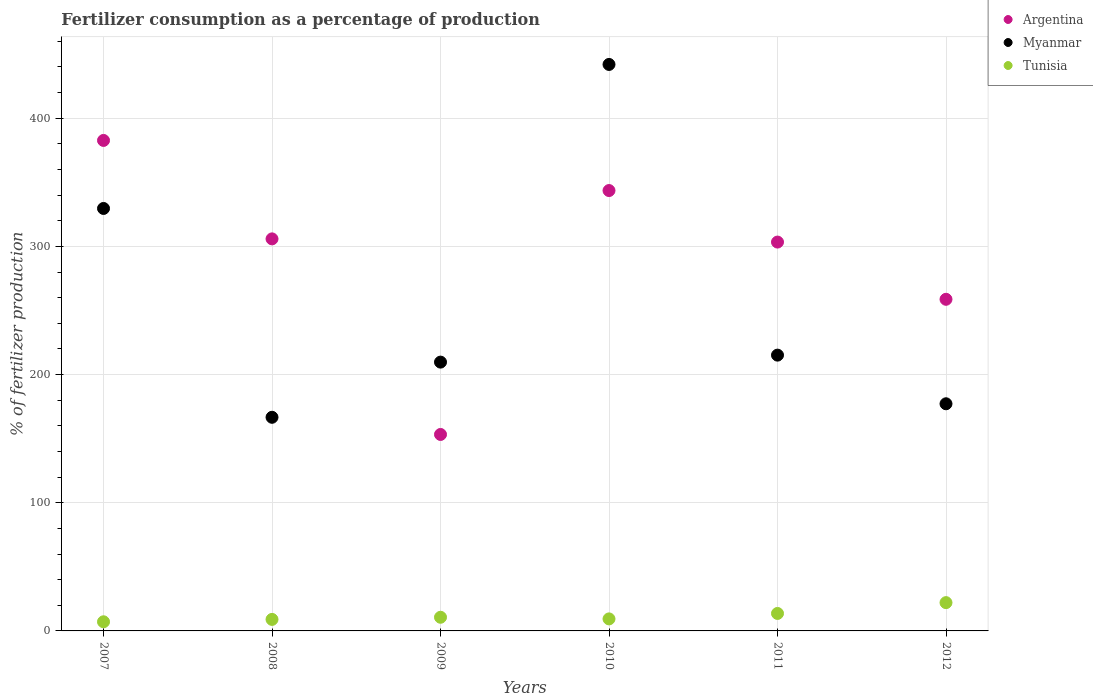Is the number of dotlines equal to the number of legend labels?
Your answer should be compact. Yes. What is the percentage of fertilizers consumed in Myanmar in 2008?
Make the answer very short. 166.68. Across all years, what is the maximum percentage of fertilizers consumed in Myanmar?
Offer a very short reply. 441.98. Across all years, what is the minimum percentage of fertilizers consumed in Argentina?
Offer a very short reply. 153.28. In which year was the percentage of fertilizers consumed in Tunisia maximum?
Offer a terse response. 2012. What is the total percentage of fertilizers consumed in Argentina in the graph?
Your answer should be very brief. 1747.57. What is the difference between the percentage of fertilizers consumed in Argentina in 2009 and that in 2010?
Give a very brief answer. -190.31. What is the difference between the percentage of fertilizers consumed in Myanmar in 2008 and the percentage of fertilizers consumed in Argentina in 2010?
Offer a very short reply. -176.91. What is the average percentage of fertilizers consumed in Argentina per year?
Keep it short and to the point. 291.26. In the year 2008, what is the difference between the percentage of fertilizers consumed in Tunisia and percentage of fertilizers consumed in Argentina?
Ensure brevity in your answer.  -296.9. What is the ratio of the percentage of fertilizers consumed in Myanmar in 2007 to that in 2012?
Provide a short and direct response. 1.86. Is the percentage of fertilizers consumed in Tunisia in 2010 less than that in 2012?
Give a very brief answer. Yes. What is the difference between the highest and the second highest percentage of fertilizers consumed in Argentina?
Your answer should be compact. 39.1. What is the difference between the highest and the lowest percentage of fertilizers consumed in Tunisia?
Your response must be concise. 14.94. Is the sum of the percentage of fertilizers consumed in Argentina in 2007 and 2009 greater than the maximum percentage of fertilizers consumed in Myanmar across all years?
Your response must be concise. Yes. Is the percentage of fertilizers consumed in Argentina strictly greater than the percentage of fertilizers consumed in Tunisia over the years?
Ensure brevity in your answer.  Yes. How many dotlines are there?
Provide a succinct answer. 3. How many years are there in the graph?
Offer a very short reply. 6. What is the difference between two consecutive major ticks on the Y-axis?
Your answer should be compact. 100. Are the values on the major ticks of Y-axis written in scientific E-notation?
Your answer should be compact. No. Where does the legend appear in the graph?
Provide a short and direct response. Top right. How many legend labels are there?
Ensure brevity in your answer.  3. How are the legend labels stacked?
Your response must be concise. Vertical. What is the title of the graph?
Offer a very short reply. Fertilizer consumption as a percentage of production. What is the label or title of the X-axis?
Your answer should be very brief. Years. What is the label or title of the Y-axis?
Offer a terse response. % of fertilizer production. What is the % of fertilizer production of Argentina in 2007?
Your answer should be very brief. 382.69. What is the % of fertilizer production in Myanmar in 2007?
Your answer should be compact. 329.61. What is the % of fertilizer production of Tunisia in 2007?
Provide a succinct answer. 7.13. What is the % of fertilizer production of Argentina in 2008?
Provide a short and direct response. 305.88. What is the % of fertilizer production in Myanmar in 2008?
Offer a very short reply. 166.68. What is the % of fertilizer production of Tunisia in 2008?
Offer a terse response. 8.99. What is the % of fertilizer production of Argentina in 2009?
Your answer should be compact. 153.28. What is the % of fertilizer production of Myanmar in 2009?
Offer a very short reply. 209.73. What is the % of fertilizer production of Tunisia in 2009?
Provide a succinct answer. 10.66. What is the % of fertilizer production of Argentina in 2010?
Give a very brief answer. 343.59. What is the % of fertilizer production of Myanmar in 2010?
Ensure brevity in your answer.  441.98. What is the % of fertilizer production of Tunisia in 2010?
Make the answer very short. 9.38. What is the % of fertilizer production of Argentina in 2011?
Make the answer very short. 303.39. What is the % of fertilizer production in Myanmar in 2011?
Your response must be concise. 215.18. What is the % of fertilizer production of Tunisia in 2011?
Offer a very short reply. 13.63. What is the % of fertilizer production of Argentina in 2012?
Give a very brief answer. 258.74. What is the % of fertilizer production in Myanmar in 2012?
Provide a succinct answer. 177.22. What is the % of fertilizer production in Tunisia in 2012?
Offer a very short reply. 22.07. Across all years, what is the maximum % of fertilizer production in Argentina?
Your response must be concise. 382.69. Across all years, what is the maximum % of fertilizer production in Myanmar?
Your answer should be compact. 441.98. Across all years, what is the maximum % of fertilizer production in Tunisia?
Make the answer very short. 22.07. Across all years, what is the minimum % of fertilizer production in Argentina?
Keep it short and to the point. 153.28. Across all years, what is the minimum % of fertilizer production in Myanmar?
Provide a short and direct response. 166.68. Across all years, what is the minimum % of fertilizer production in Tunisia?
Keep it short and to the point. 7.13. What is the total % of fertilizer production of Argentina in the graph?
Make the answer very short. 1747.57. What is the total % of fertilizer production of Myanmar in the graph?
Ensure brevity in your answer.  1540.39. What is the total % of fertilizer production of Tunisia in the graph?
Offer a terse response. 71.85. What is the difference between the % of fertilizer production in Argentina in 2007 and that in 2008?
Ensure brevity in your answer.  76.81. What is the difference between the % of fertilizer production in Myanmar in 2007 and that in 2008?
Your response must be concise. 162.93. What is the difference between the % of fertilizer production in Tunisia in 2007 and that in 2008?
Make the answer very short. -1.86. What is the difference between the % of fertilizer production of Argentina in 2007 and that in 2009?
Offer a very short reply. 229.41. What is the difference between the % of fertilizer production in Myanmar in 2007 and that in 2009?
Offer a terse response. 119.89. What is the difference between the % of fertilizer production in Tunisia in 2007 and that in 2009?
Offer a terse response. -3.53. What is the difference between the % of fertilizer production in Argentina in 2007 and that in 2010?
Provide a short and direct response. 39.1. What is the difference between the % of fertilizer production of Myanmar in 2007 and that in 2010?
Provide a short and direct response. -112.36. What is the difference between the % of fertilizer production of Tunisia in 2007 and that in 2010?
Keep it short and to the point. -2.25. What is the difference between the % of fertilizer production in Argentina in 2007 and that in 2011?
Ensure brevity in your answer.  79.3. What is the difference between the % of fertilizer production in Myanmar in 2007 and that in 2011?
Give a very brief answer. 114.44. What is the difference between the % of fertilizer production of Tunisia in 2007 and that in 2011?
Make the answer very short. -6.5. What is the difference between the % of fertilizer production of Argentina in 2007 and that in 2012?
Offer a very short reply. 123.95. What is the difference between the % of fertilizer production in Myanmar in 2007 and that in 2012?
Give a very brief answer. 152.39. What is the difference between the % of fertilizer production in Tunisia in 2007 and that in 2012?
Provide a short and direct response. -14.94. What is the difference between the % of fertilizer production of Argentina in 2008 and that in 2009?
Your response must be concise. 152.6. What is the difference between the % of fertilizer production of Myanmar in 2008 and that in 2009?
Your answer should be compact. -43.05. What is the difference between the % of fertilizer production in Tunisia in 2008 and that in 2009?
Make the answer very short. -1.67. What is the difference between the % of fertilizer production of Argentina in 2008 and that in 2010?
Give a very brief answer. -37.71. What is the difference between the % of fertilizer production in Myanmar in 2008 and that in 2010?
Offer a terse response. -275.3. What is the difference between the % of fertilizer production of Tunisia in 2008 and that in 2010?
Provide a short and direct response. -0.4. What is the difference between the % of fertilizer production of Argentina in 2008 and that in 2011?
Your answer should be compact. 2.49. What is the difference between the % of fertilizer production of Myanmar in 2008 and that in 2011?
Your response must be concise. -48.5. What is the difference between the % of fertilizer production of Tunisia in 2008 and that in 2011?
Keep it short and to the point. -4.65. What is the difference between the % of fertilizer production of Argentina in 2008 and that in 2012?
Offer a terse response. 47.14. What is the difference between the % of fertilizer production of Myanmar in 2008 and that in 2012?
Your response must be concise. -10.54. What is the difference between the % of fertilizer production of Tunisia in 2008 and that in 2012?
Keep it short and to the point. -13.08. What is the difference between the % of fertilizer production of Argentina in 2009 and that in 2010?
Keep it short and to the point. -190.31. What is the difference between the % of fertilizer production in Myanmar in 2009 and that in 2010?
Your response must be concise. -232.25. What is the difference between the % of fertilizer production in Tunisia in 2009 and that in 2010?
Your response must be concise. 1.27. What is the difference between the % of fertilizer production in Argentina in 2009 and that in 2011?
Your answer should be compact. -150.11. What is the difference between the % of fertilizer production in Myanmar in 2009 and that in 2011?
Give a very brief answer. -5.45. What is the difference between the % of fertilizer production of Tunisia in 2009 and that in 2011?
Provide a succinct answer. -2.97. What is the difference between the % of fertilizer production of Argentina in 2009 and that in 2012?
Provide a short and direct response. -105.46. What is the difference between the % of fertilizer production in Myanmar in 2009 and that in 2012?
Offer a very short reply. 32.51. What is the difference between the % of fertilizer production in Tunisia in 2009 and that in 2012?
Ensure brevity in your answer.  -11.41. What is the difference between the % of fertilizer production of Argentina in 2010 and that in 2011?
Offer a very short reply. 40.2. What is the difference between the % of fertilizer production of Myanmar in 2010 and that in 2011?
Keep it short and to the point. 226.8. What is the difference between the % of fertilizer production in Tunisia in 2010 and that in 2011?
Keep it short and to the point. -4.25. What is the difference between the % of fertilizer production in Argentina in 2010 and that in 2012?
Your answer should be compact. 84.85. What is the difference between the % of fertilizer production in Myanmar in 2010 and that in 2012?
Your response must be concise. 264.76. What is the difference between the % of fertilizer production in Tunisia in 2010 and that in 2012?
Keep it short and to the point. -12.69. What is the difference between the % of fertilizer production of Argentina in 2011 and that in 2012?
Your response must be concise. 44.65. What is the difference between the % of fertilizer production in Myanmar in 2011 and that in 2012?
Make the answer very short. 37.96. What is the difference between the % of fertilizer production of Tunisia in 2011 and that in 2012?
Offer a very short reply. -8.44. What is the difference between the % of fertilizer production in Argentina in 2007 and the % of fertilizer production in Myanmar in 2008?
Your answer should be very brief. 216.01. What is the difference between the % of fertilizer production of Argentina in 2007 and the % of fertilizer production of Tunisia in 2008?
Offer a very short reply. 373.7. What is the difference between the % of fertilizer production in Myanmar in 2007 and the % of fertilizer production in Tunisia in 2008?
Your response must be concise. 320.63. What is the difference between the % of fertilizer production in Argentina in 2007 and the % of fertilizer production in Myanmar in 2009?
Make the answer very short. 172.96. What is the difference between the % of fertilizer production in Argentina in 2007 and the % of fertilizer production in Tunisia in 2009?
Provide a short and direct response. 372.03. What is the difference between the % of fertilizer production in Myanmar in 2007 and the % of fertilizer production in Tunisia in 2009?
Give a very brief answer. 318.96. What is the difference between the % of fertilizer production of Argentina in 2007 and the % of fertilizer production of Myanmar in 2010?
Offer a terse response. -59.29. What is the difference between the % of fertilizer production of Argentina in 2007 and the % of fertilizer production of Tunisia in 2010?
Your answer should be compact. 373.3. What is the difference between the % of fertilizer production of Myanmar in 2007 and the % of fertilizer production of Tunisia in 2010?
Ensure brevity in your answer.  320.23. What is the difference between the % of fertilizer production of Argentina in 2007 and the % of fertilizer production of Myanmar in 2011?
Your answer should be compact. 167.51. What is the difference between the % of fertilizer production of Argentina in 2007 and the % of fertilizer production of Tunisia in 2011?
Keep it short and to the point. 369.06. What is the difference between the % of fertilizer production in Myanmar in 2007 and the % of fertilizer production in Tunisia in 2011?
Offer a terse response. 315.98. What is the difference between the % of fertilizer production of Argentina in 2007 and the % of fertilizer production of Myanmar in 2012?
Provide a short and direct response. 205.47. What is the difference between the % of fertilizer production of Argentina in 2007 and the % of fertilizer production of Tunisia in 2012?
Your answer should be compact. 360.62. What is the difference between the % of fertilizer production of Myanmar in 2007 and the % of fertilizer production of Tunisia in 2012?
Provide a succinct answer. 307.54. What is the difference between the % of fertilizer production of Argentina in 2008 and the % of fertilizer production of Myanmar in 2009?
Your response must be concise. 96.15. What is the difference between the % of fertilizer production of Argentina in 2008 and the % of fertilizer production of Tunisia in 2009?
Provide a short and direct response. 295.22. What is the difference between the % of fertilizer production in Myanmar in 2008 and the % of fertilizer production in Tunisia in 2009?
Your answer should be compact. 156.02. What is the difference between the % of fertilizer production in Argentina in 2008 and the % of fertilizer production in Myanmar in 2010?
Offer a terse response. -136.1. What is the difference between the % of fertilizer production of Argentina in 2008 and the % of fertilizer production of Tunisia in 2010?
Your answer should be compact. 296.5. What is the difference between the % of fertilizer production in Myanmar in 2008 and the % of fertilizer production in Tunisia in 2010?
Your response must be concise. 157.3. What is the difference between the % of fertilizer production of Argentina in 2008 and the % of fertilizer production of Myanmar in 2011?
Give a very brief answer. 90.7. What is the difference between the % of fertilizer production of Argentina in 2008 and the % of fertilizer production of Tunisia in 2011?
Keep it short and to the point. 292.25. What is the difference between the % of fertilizer production in Myanmar in 2008 and the % of fertilizer production in Tunisia in 2011?
Your answer should be compact. 153.05. What is the difference between the % of fertilizer production of Argentina in 2008 and the % of fertilizer production of Myanmar in 2012?
Your response must be concise. 128.66. What is the difference between the % of fertilizer production of Argentina in 2008 and the % of fertilizer production of Tunisia in 2012?
Ensure brevity in your answer.  283.81. What is the difference between the % of fertilizer production of Myanmar in 2008 and the % of fertilizer production of Tunisia in 2012?
Your response must be concise. 144.61. What is the difference between the % of fertilizer production in Argentina in 2009 and the % of fertilizer production in Myanmar in 2010?
Offer a terse response. -288.7. What is the difference between the % of fertilizer production in Argentina in 2009 and the % of fertilizer production in Tunisia in 2010?
Your response must be concise. 143.9. What is the difference between the % of fertilizer production in Myanmar in 2009 and the % of fertilizer production in Tunisia in 2010?
Offer a terse response. 200.34. What is the difference between the % of fertilizer production in Argentina in 2009 and the % of fertilizer production in Myanmar in 2011?
Keep it short and to the point. -61.9. What is the difference between the % of fertilizer production of Argentina in 2009 and the % of fertilizer production of Tunisia in 2011?
Make the answer very short. 139.65. What is the difference between the % of fertilizer production of Myanmar in 2009 and the % of fertilizer production of Tunisia in 2011?
Your answer should be very brief. 196.1. What is the difference between the % of fertilizer production of Argentina in 2009 and the % of fertilizer production of Myanmar in 2012?
Your answer should be very brief. -23.94. What is the difference between the % of fertilizer production in Argentina in 2009 and the % of fertilizer production in Tunisia in 2012?
Give a very brief answer. 131.21. What is the difference between the % of fertilizer production in Myanmar in 2009 and the % of fertilizer production in Tunisia in 2012?
Provide a succinct answer. 187.66. What is the difference between the % of fertilizer production of Argentina in 2010 and the % of fertilizer production of Myanmar in 2011?
Your answer should be compact. 128.41. What is the difference between the % of fertilizer production in Argentina in 2010 and the % of fertilizer production in Tunisia in 2011?
Your response must be concise. 329.96. What is the difference between the % of fertilizer production in Myanmar in 2010 and the % of fertilizer production in Tunisia in 2011?
Keep it short and to the point. 428.35. What is the difference between the % of fertilizer production of Argentina in 2010 and the % of fertilizer production of Myanmar in 2012?
Your answer should be very brief. 166.37. What is the difference between the % of fertilizer production in Argentina in 2010 and the % of fertilizer production in Tunisia in 2012?
Your response must be concise. 321.52. What is the difference between the % of fertilizer production of Myanmar in 2010 and the % of fertilizer production of Tunisia in 2012?
Provide a short and direct response. 419.91. What is the difference between the % of fertilizer production in Argentina in 2011 and the % of fertilizer production in Myanmar in 2012?
Provide a succinct answer. 126.17. What is the difference between the % of fertilizer production of Argentina in 2011 and the % of fertilizer production of Tunisia in 2012?
Make the answer very short. 281.32. What is the difference between the % of fertilizer production in Myanmar in 2011 and the % of fertilizer production in Tunisia in 2012?
Your response must be concise. 193.11. What is the average % of fertilizer production in Argentina per year?
Your answer should be very brief. 291.26. What is the average % of fertilizer production in Myanmar per year?
Make the answer very short. 256.73. What is the average % of fertilizer production in Tunisia per year?
Ensure brevity in your answer.  11.98. In the year 2007, what is the difference between the % of fertilizer production of Argentina and % of fertilizer production of Myanmar?
Offer a terse response. 53.08. In the year 2007, what is the difference between the % of fertilizer production in Argentina and % of fertilizer production in Tunisia?
Your answer should be very brief. 375.56. In the year 2007, what is the difference between the % of fertilizer production in Myanmar and % of fertilizer production in Tunisia?
Keep it short and to the point. 322.48. In the year 2008, what is the difference between the % of fertilizer production of Argentina and % of fertilizer production of Myanmar?
Provide a succinct answer. 139.2. In the year 2008, what is the difference between the % of fertilizer production in Argentina and % of fertilizer production in Tunisia?
Offer a very short reply. 296.89. In the year 2008, what is the difference between the % of fertilizer production of Myanmar and % of fertilizer production of Tunisia?
Ensure brevity in your answer.  157.69. In the year 2009, what is the difference between the % of fertilizer production of Argentina and % of fertilizer production of Myanmar?
Your answer should be compact. -56.45. In the year 2009, what is the difference between the % of fertilizer production of Argentina and % of fertilizer production of Tunisia?
Offer a terse response. 142.62. In the year 2009, what is the difference between the % of fertilizer production in Myanmar and % of fertilizer production in Tunisia?
Your answer should be compact. 199.07. In the year 2010, what is the difference between the % of fertilizer production in Argentina and % of fertilizer production in Myanmar?
Provide a short and direct response. -98.39. In the year 2010, what is the difference between the % of fertilizer production in Argentina and % of fertilizer production in Tunisia?
Your answer should be very brief. 334.2. In the year 2010, what is the difference between the % of fertilizer production of Myanmar and % of fertilizer production of Tunisia?
Keep it short and to the point. 432.59. In the year 2011, what is the difference between the % of fertilizer production of Argentina and % of fertilizer production of Myanmar?
Provide a succinct answer. 88.21. In the year 2011, what is the difference between the % of fertilizer production in Argentina and % of fertilizer production in Tunisia?
Offer a terse response. 289.76. In the year 2011, what is the difference between the % of fertilizer production in Myanmar and % of fertilizer production in Tunisia?
Your answer should be compact. 201.55. In the year 2012, what is the difference between the % of fertilizer production in Argentina and % of fertilizer production in Myanmar?
Ensure brevity in your answer.  81.52. In the year 2012, what is the difference between the % of fertilizer production in Argentina and % of fertilizer production in Tunisia?
Your answer should be compact. 236.67. In the year 2012, what is the difference between the % of fertilizer production in Myanmar and % of fertilizer production in Tunisia?
Provide a short and direct response. 155.15. What is the ratio of the % of fertilizer production in Argentina in 2007 to that in 2008?
Provide a succinct answer. 1.25. What is the ratio of the % of fertilizer production of Myanmar in 2007 to that in 2008?
Offer a very short reply. 1.98. What is the ratio of the % of fertilizer production of Tunisia in 2007 to that in 2008?
Your answer should be very brief. 0.79. What is the ratio of the % of fertilizer production of Argentina in 2007 to that in 2009?
Provide a short and direct response. 2.5. What is the ratio of the % of fertilizer production of Myanmar in 2007 to that in 2009?
Offer a very short reply. 1.57. What is the ratio of the % of fertilizer production in Tunisia in 2007 to that in 2009?
Offer a terse response. 0.67. What is the ratio of the % of fertilizer production in Argentina in 2007 to that in 2010?
Offer a terse response. 1.11. What is the ratio of the % of fertilizer production in Myanmar in 2007 to that in 2010?
Provide a short and direct response. 0.75. What is the ratio of the % of fertilizer production in Tunisia in 2007 to that in 2010?
Keep it short and to the point. 0.76. What is the ratio of the % of fertilizer production of Argentina in 2007 to that in 2011?
Offer a very short reply. 1.26. What is the ratio of the % of fertilizer production in Myanmar in 2007 to that in 2011?
Keep it short and to the point. 1.53. What is the ratio of the % of fertilizer production in Tunisia in 2007 to that in 2011?
Give a very brief answer. 0.52. What is the ratio of the % of fertilizer production of Argentina in 2007 to that in 2012?
Your response must be concise. 1.48. What is the ratio of the % of fertilizer production of Myanmar in 2007 to that in 2012?
Your answer should be compact. 1.86. What is the ratio of the % of fertilizer production in Tunisia in 2007 to that in 2012?
Provide a short and direct response. 0.32. What is the ratio of the % of fertilizer production of Argentina in 2008 to that in 2009?
Your answer should be compact. 2. What is the ratio of the % of fertilizer production in Myanmar in 2008 to that in 2009?
Ensure brevity in your answer.  0.79. What is the ratio of the % of fertilizer production of Tunisia in 2008 to that in 2009?
Offer a very short reply. 0.84. What is the ratio of the % of fertilizer production of Argentina in 2008 to that in 2010?
Offer a very short reply. 0.89. What is the ratio of the % of fertilizer production of Myanmar in 2008 to that in 2010?
Give a very brief answer. 0.38. What is the ratio of the % of fertilizer production in Tunisia in 2008 to that in 2010?
Your response must be concise. 0.96. What is the ratio of the % of fertilizer production of Argentina in 2008 to that in 2011?
Your answer should be compact. 1.01. What is the ratio of the % of fertilizer production in Myanmar in 2008 to that in 2011?
Make the answer very short. 0.77. What is the ratio of the % of fertilizer production in Tunisia in 2008 to that in 2011?
Make the answer very short. 0.66. What is the ratio of the % of fertilizer production in Argentina in 2008 to that in 2012?
Ensure brevity in your answer.  1.18. What is the ratio of the % of fertilizer production in Myanmar in 2008 to that in 2012?
Offer a very short reply. 0.94. What is the ratio of the % of fertilizer production in Tunisia in 2008 to that in 2012?
Provide a short and direct response. 0.41. What is the ratio of the % of fertilizer production of Argentina in 2009 to that in 2010?
Provide a short and direct response. 0.45. What is the ratio of the % of fertilizer production of Myanmar in 2009 to that in 2010?
Make the answer very short. 0.47. What is the ratio of the % of fertilizer production in Tunisia in 2009 to that in 2010?
Your answer should be very brief. 1.14. What is the ratio of the % of fertilizer production in Argentina in 2009 to that in 2011?
Keep it short and to the point. 0.51. What is the ratio of the % of fertilizer production in Myanmar in 2009 to that in 2011?
Provide a succinct answer. 0.97. What is the ratio of the % of fertilizer production in Tunisia in 2009 to that in 2011?
Your response must be concise. 0.78. What is the ratio of the % of fertilizer production of Argentina in 2009 to that in 2012?
Give a very brief answer. 0.59. What is the ratio of the % of fertilizer production in Myanmar in 2009 to that in 2012?
Provide a succinct answer. 1.18. What is the ratio of the % of fertilizer production in Tunisia in 2009 to that in 2012?
Make the answer very short. 0.48. What is the ratio of the % of fertilizer production in Argentina in 2010 to that in 2011?
Keep it short and to the point. 1.13. What is the ratio of the % of fertilizer production in Myanmar in 2010 to that in 2011?
Make the answer very short. 2.05. What is the ratio of the % of fertilizer production of Tunisia in 2010 to that in 2011?
Provide a short and direct response. 0.69. What is the ratio of the % of fertilizer production of Argentina in 2010 to that in 2012?
Give a very brief answer. 1.33. What is the ratio of the % of fertilizer production in Myanmar in 2010 to that in 2012?
Give a very brief answer. 2.49. What is the ratio of the % of fertilizer production of Tunisia in 2010 to that in 2012?
Provide a short and direct response. 0.43. What is the ratio of the % of fertilizer production in Argentina in 2011 to that in 2012?
Provide a short and direct response. 1.17. What is the ratio of the % of fertilizer production in Myanmar in 2011 to that in 2012?
Provide a short and direct response. 1.21. What is the ratio of the % of fertilizer production of Tunisia in 2011 to that in 2012?
Your answer should be compact. 0.62. What is the difference between the highest and the second highest % of fertilizer production in Argentina?
Offer a very short reply. 39.1. What is the difference between the highest and the second highest % of fertilizer production in Myanmar?
Your answer should be compact. 112.36. What is the difference between the highest and the second highest % of fertilizer production in Tunisia?
Make the answer very short. 8.44. What is the difference between the highest and the lowest % of fertilizer production in Argentina?
Offer a very short reply. 229.41. What is the difference between the highest and the lowest % of fertilizer production in Myanmar?
Make the answer very short. 275.3. What is the difference between the highest and the lowest % of fertilizer production of Tunisia?
Give a very brief answer. 14.94. 